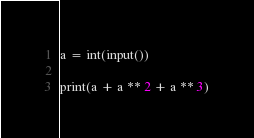<code> <loc_0><loc_0><loc_500><loc_500><_Python_>a = int(input())

print(a + a ** 2 + a ** 3)</code> 